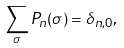<formula> <loc_0><loc_0><loc_500><loc_500>\sum _ { \sigma } P _ { n } ( \sigma ) = \delta _ { n , 0 } ,</formula> 